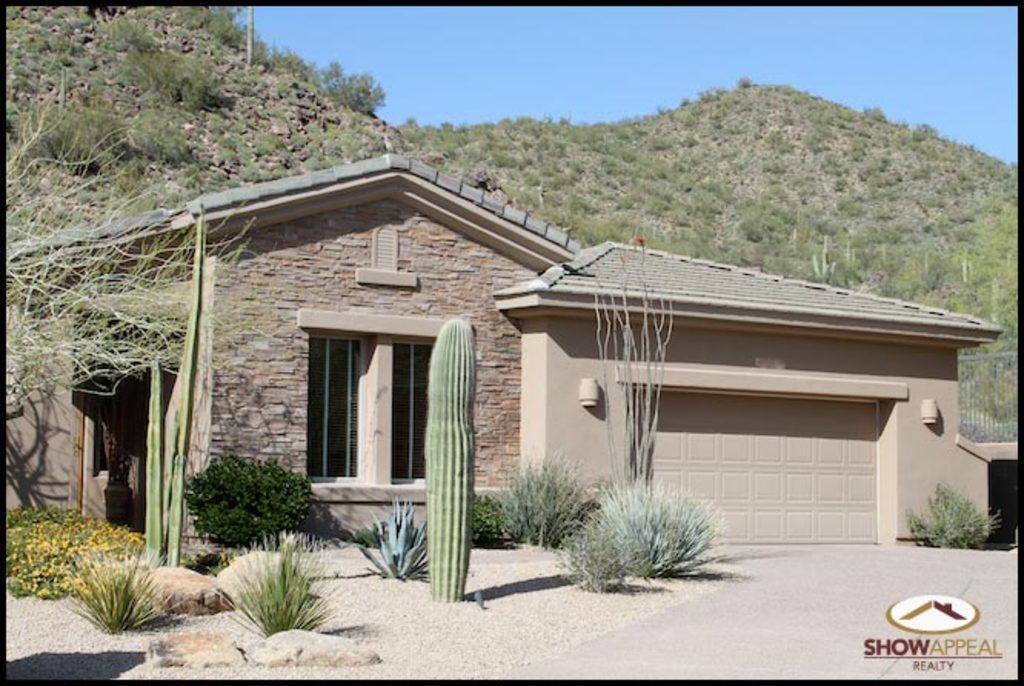Please provide a concise description of this image. In this image we can see a house which is of stone wall, there is door, window and at the background of the image there is mountain and clear sky. 